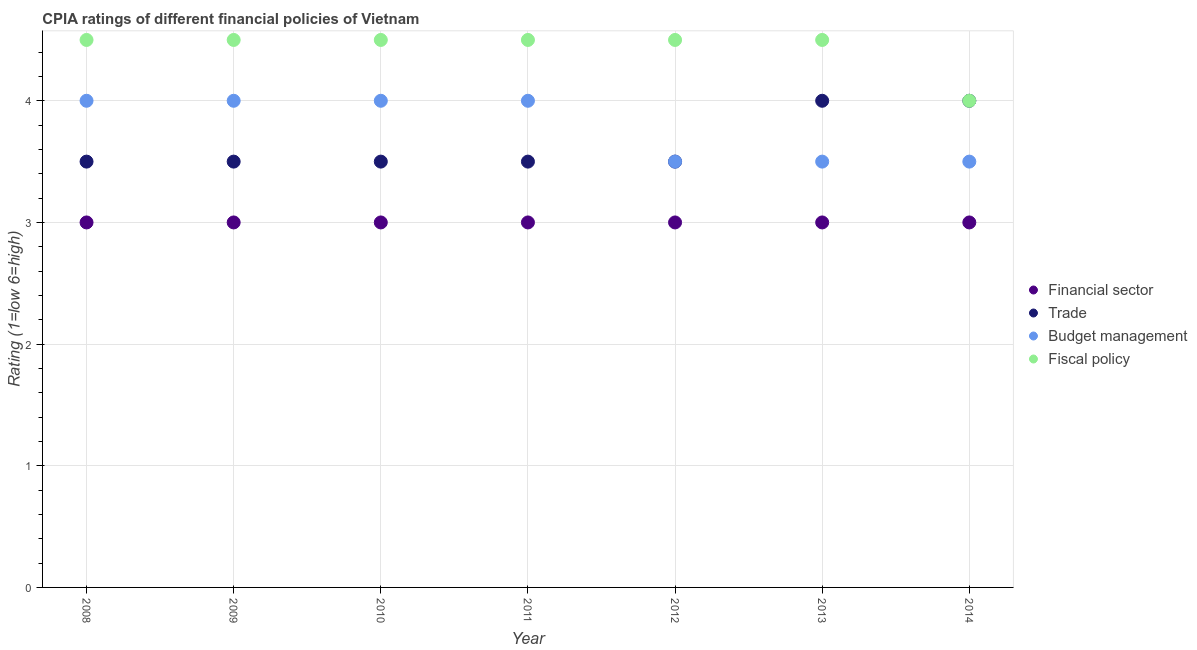Is the number of dotlines equal to the number of legend labels?
Provide a succinct answer. Yes. What is the cpia rating of budget management in 2009?
Your response must be concise. 4. Across all years, what is the maximum cpia rating of financial sector?
Ensure brevity in your answer.  3. In which year was the cpia rating of trade minimum?
Give a very brief answer. 2008. What is the total cpia rating of financial sector in the graph?
Make the answer very short. 21. What is the average cpia rating of fiscal policy per year?
Offer a very short reply. 4.43. In how many years, is the cpia rating of trade greater than 0.4?
Your response must be concise. 7. Is the cpia rating of financial sector in 2008 less than that in 2010?
Offer a very short reply. No. What is the difference between the highest and the second highest cpia rating of financial sector?
Make the answer very short. 0. In how many years, is the cpia rating of budget management greater than the average cpia rating of budget management taken over all years?
Your answer should be very brief. 4. Is it the case that in every year, the sum of the cpia rating of fiscal policy and cpia rating of budget management is greater than the sum of cpia rating of trade and cpia rating of financial sector?
Give a very brief answer. No. Is it the case that in every year, the sum of the cpia rating of financial sector and cpia rating of trade is greater than the cpia rating of budget management?
Offer a very short reply. Yes. Is the cpia rating of fiscal policy strictly greater than the cpia rating of financial sector over the years?
Make the answer very short. Yes. How many dotlines are there?
Your answer should be compact. 4. What is the difference between two consecutive major ticks on the Y-axis?
Your response must be concise. 1. How are the legend labels stacked?
Ensure brevity in your answer.  Vertical. What is the title of the graph?
Your response must be concise. CPIA ratings of different financial policies of Vietnam. What is the label or title of the X-axis?
Keep it short and to the point. Year. What is the label or title of the Y-axis?
Your answer should be very brief. Rating (1=low 6=high). What is the Rating (1=low 6=high) of Financial sector in 2008?
Offer a terse response. 3. What is the Rating (1=low 6=high) of Budget management in 2008?
Keep it short and to the point. 4. What is the Rating (1=low 6=high) of Fiscal policy in 2008?
Your response must be concise. 4.5. What is the Rating (1=low 6=high) of Trade in 2009?
Your answer should be compact. 3.5. What is the Rating (1=low 6=high) in Financial sector in 2010?
Provide a short and direct response. 3. What is the Rating (1=low 6=high) of Budget management in 2010?
Give a very brief answer. 4. What is the Rating (1=low 6=high) in Financial sector in 2011?
Offer a very short reply. 3. What is the Rating (1=low 6=high) of Budget management in 2011?
Your answer should be very brief. 4. What is the Rating (1=low 6=high) in Fiscal policy in 2011?
Make the answer very short. 4.5. What is the Rating (1=low 6=high) in Fiscal policy in 2012?
Provide a short and direct response. 4.5. What is the Rating (1=low 6=high) of Trade in 2013?
Offer a terse response. 4. What is the Rating (1=low 6=high) of Budget management in 2013?
Offer a terse response. 3.5. What is the Rating (1=low 6=high) of Fiscal policy in 2013?
Your answer should be very brief. 4.5. What is the Rating (1=low 6=high) in Financial sector in 2014?
Your answer should be compact. 3. What is the Rating (1=low 6=high) in Trade in 2014?
Provide a short and direct response. 4. What is the Rating (1=low 6=high) in Budget management in 2014?
Offer a very short reply. 3.5. Across all years, what is the maximum Rating (1=low 6=high) in Financial sector?
Your answer should be very brief. 3. Across all years, what is the maximum Rating (1=low 6=high) of Fiscal policy?
Provide a short and direct response. 4.5. Across all years, what is the minimum Rating (1=low 6=high) in Financial sector?
Give a very brief answer. 3. What is the total Rating (1=low 6=high) of Trade in the graph?
Offer a terse response. 25.5. What is the difference between the Rating (1=low 6=high) in Financial sector in 2008 and that in 2009?
Give a very brief answer. 0. What is the difference between the Rating (1=low 6=high) in Budget management in 2008 and that in 2009?
Offer a very short reply. 0. What is the difference between the Rating (1=low 6=high) in Trade in 2008 and that in 2010?
Your answer should be very brief. 0. What is the difference between the Rating (1=low 6=high) in Fiscal policy in 2008 and that in 2010?
Provide a short and direct response. 0. What is the difference between the Rating (1=low 6=high) in Financial sector in 2008 and that in 2011?
Your answer should be compact. 0. What is the difference between the Rating (1=low 6=high) in Trade in 2008 and that in 2011?
Your response must be concise. 0. What is the difference between the Rating (1=low 6=high) of Budget management in 2008 and that in 2011?
Keep it short and to the point. 0. What is the difference between the Rating (1=low 6=high) in Financial sector in 2008 and that in 2012?
Your response must be concise. 0. What is the difference between the Rating (1=low 6=high) in Trade in 2008 and that in 2012?
Ensure brevity in your answer.  0. What is the difference between the Rating (1=low 6=high) of Trade in 2008 and that in 2013?
Your response must be concise. -0.5. What is the difference between the Rating (1=low 6=high) in Budget management in 2009 and that in 2010?
Provide a short and direct response. 0. What is the difference between the Rating (1=low 6=high) of Trade in 2009 and that in 2011?
Provide a succinct answer. 0. What is the difference between the Rating (1=low 6=high) in Fiscal policy in 2009 and that in 2011?
Give a very brief answer. 0. What is the difference between the Rating (1=low 6=high) of Financial sector in 2009 and that in 2012?
Provide a short and direct response. 0. What is the difference between the Rating (1=low 6=high) of Trade in 2009 and that in 2012?
Give a very brief answer. 0. What is the difference between the Rating (1=low 6=high) of Fiscal policy in 2009 and that in 2012?
Offer a very short reply. 0. What is the difference between the Rating (1=low 6=high) of Trade in 2009 and that in 2013?
Provide a short and direct response. -0.5. What is the difference between the Rating (1=low 6=high) of Trade in 2009 and that in 2014?
Make the answer very short. -0.5. What is the difference between the Rating (1=low 6=high) in Budget management in 2009 and that in 2014?
Your answer should be very brief. 0.5. What is the difference between the Rating (1=low 6=high) of Financial sector in 2010 and that in 2011?
Give a very brief answer. 0. What is the difference between the Rating (1=low 6=high) of Budget management in 2010 and that in 2011?
Offer a terse response. 0. What is the difference between the Rating (1=low 6=high) of Financial sector in 2010 and that in 2012?
Your answer should be very brief. 0. What is the difference between the Rating (1=low 6=high) in Financial sector in 2010 and that in 2013?
Your answer should be compact. 0. What is the difference between the Rating (1=low 6=high) of Budget management in 2010 and that in 2013?
Give a very brief answer. 0.5. What is the difference between the Rating (1=low 6=high) in Fiscal policy in 2010 and that in 2013?
Offer a terse response. 0. What is the difference between the Rating (1=low 6=high) in Financial sector in 2010 and that in 2014?
Make the answer very short. 0. What is the difference between the Rating (1=low 6=high) of Trade in 2010 and that in 2014?
Your response must be concise. -0.5. What is the difference between the Rating (1=low 6=high) in Budget management in 2010 and that in 2014?
Give a very brief answer. 0.5. What is the difference between the Rating (1=low 6=high) in Fiscal policy in 2010 and that in 2014?
Keep it short and to the point. 0.5. What is the difference between the Rating (1=low 6=high) in Financial sector in 2011 and that in 2012?
Provide a succinct answer. 0. What is the difference between the Rating (1=low 6=high) in Trade in 2011 and that in 2012?
Ensure brevity in your answer.  0. What is the difference between the Rating (1=low 6=high) of Trade in 2011 and that in 2013?
Ensure brevity in your answer.  -0.5. What is the difference between the Rating (1=low 6=high) in Financial sector in 2011 and that in 2014?
Your response must be concise. 0. What is the difference between the Rating (1=low 6=high) in Budget management in 2012 and that in 2013?
Ensure brevity in your answer.  0. What is the difference between the Rating (1=low 6=high) in Fiscal policy in 2012 and that in 2014?
Ensure brevity in your answer.  0.5. What is the difference between the Rating (1=low 6=high) of Trade in 2013 and that in 2014?
Your answer should be very brief. 0. What is the difference between the Rating (1=low 6=high) of Budget management in 2013 and that in 2014?
Offer a very short reply. 0. What is the difference between the Rating (1=low 6=high) of Fiscal policy in 2013 and that in 2014?
Provide a short and direct response. 0.5. What is the difference between the Rating (1=low 6=high) of Financial sector in 2008 and the Rating (1=low 6=high) of Budget management in 2009?
Provide a succinct answer. -1. What is the difference between the Rating (1=low 6=high) in Financial sector in 2008 and the Rating (1=low 6=high) in Fiscal policy in 2009?
Your answer should be very brief. -1.5. What is the difference between the Rating (1=low 6=high) of Trade in 2008 and the Rating (1=low 6=high) of Budget management in 2009?
Give a very brief answer. -0.5. What is the difference between the Rating (1=low 6=high) in Budget management in 2008 and the Rating (1=low 6=high) in Fiscal policy in 2009?
Your answer should be very brief. -0.5. What is the difference between the Rating (1=low 6=high) in Financial sector in 2008 and the Rating (1=low 6=high) in Budget management in 2010?
Give a very brief answer. -1. What is the difference between the Rating (1=low 6=high) in Financial sector in 2008 and the Rating (1=low 6=high) in Fiscal policy in 2010?
Make the answer very short. -1.5. What is the difference between the Rating (1=low 6=high) of Trade in 2008 and the Rating (1=low 6=high) of Budget management in 2010?
Provide a short and direct response. -0.5. What is the difference between the Rating (1=low 6=high) in Trade in 2008 and the Rating (1=low 6=high) in Fiscal policy in 2010?
Provide a short and direct response. -1. What is the difference between the Rating (1=low 6=high) in Budget management in 2008 and the Rating (1=low 6=high) in Fiscal policy in 2010?
Provide a succinct answer. -0.5. What is the difference between the Rating (1=low 6=high) of Financial sector in 2008 and the Rating (1=low 6=high) of Trade in 2011?
Keep it short and to the point. -0.5. What is the difference between the Rating (1=low 6=high) in Trade in 2008 and the Rating (1=low 6=high) in Budget management in 2011?
Offer a terse response. -0.5. What is the difference between the Rating (1=low 6=high) of Trade in 2008 and the Rating (1=low 6=high) of Fiscal policy in 2011?
Ensure brevity in your answer.  -1. What is the difference between the Rating (1=low 6=high) in Budget management in 2008 and the Rating (1=low 6=high) in Fiscal policy in 2011?
Your response must be concise. -0.5. What is the difference between the Rating (1=low 6=high) of Financial sector in 2008 and the Rating (1=low 6=high) of Fiscal policy in 2012?
Your answer should be very brief. -1.5. What is the difference between the Rating (1=low 6=high) of Trade in 2008 and the Rating (1=low 6=high) of Fiscal policy in 2012?
Offer a terse response. -1. What is the difference between the Rating (1=low 6=high) in Budget management in 2008 and the Rating (1=low 6=high) in Fiscal policy in 2012?
Offer a terse response. -0.5. What is the difference between the Rating (1=low 6=high) of Trade in 2008 and the Rating (1=low 6=high) of Budget management in 2013?
Provide a succinct answer. 0. What is the difference between the Rating (1=low 6=high) in Financial sector in 2008 and the Rating (1=low 6=high) in Trade in 2014?
Provide a succinct answer. -1. What is the difference between the Rating (1=low 6=high) of Financial sector in 2008 and the Rating (1=low 6=high) of Fiscal policy in 2014?
Offer a very short reply. -1. What is the difference between the Rating (1=low 6=high) of Trade in 2008 and the Rating (1=low 6=high) of Budget management in 2014?
Offer a terse response. 0. What is the difference between the Rating (1=low 6=high) of Trade in 2008 and the Rating (1=low 6=high) of Fiscal policy in 2014?
Provide a short and direct response. -0.5. What is the difference between the Rating (1=low 6=high) in Financial sector in 2009 and the Rating (1=low 6=high) in Budget management in 2010?
Provide a short and direct response. -1. What is the difference between the Rating (1=low 6=high) in Financial sector in 2009 and the Rating (1=low 6=high) in Fiscal policy in 2010?
Make the answer very short. -1.5. What is the difference between the Rating (1=low 6=high) of Trade in 2009 and the Rating (1=low 6=high) of Budget management in 2010?
Offer a terse response. -0.5. What is the difference between the Rating (1=low 6=high) of Budget management in 2009 and the Rating (1=low 6=high) of Fiscal policy in 2010?
Provide a short and direct response. -0.5. What is the difference between the Rating (1=low 6=high) of Financial sector in 2009 and the Rating (1=low 6=high) of Budget management in 2011?
Give a very brief answer. -1. What is the difference between the Rating (1=low 6=high) of Trade in 2009 and the Rating (1=low 6=high) of Budget management in 2011?
Make the answer very short. -0.5. What is the difference between the Rating (1=low 6=high) of Financial sector in 2009 and the Rating (1=low 6=high) of Trade in 2012?
Ensure brevity in your answer.  -0.5. What is the difference between the Rating (1=low 6=high) in Trade in 2009 and the Rating (1=low 6=high) in Budget management in 2012?
Ensure brevity in your answer.  0. What is the difference between the Rating (1=low 6=high) of Financial sector in 2009 and the Rating (1=low 6=high) of Trade in 2013?
Keep it short and to the point. -1. What is the difference between the Rating (1=low 6=high) of Financial sector in 2009 and the Rating (1=low 6=high) of Fiscal policy in 2013?
Provide a short and direct response. -1.5. What is the difference between the Rating (1=low 6=high) in Budget management in 2009 and the Rating (1=low 6=high) in Fiscal policy in 2013?
Provide a short and direct response. -0.5. What is the difference between the Rating (1=low 6=high) of Financial sector in 2009 and the Rating (1=low 6=high) of Budget management in 2014?
Keep it short and to the point. -0.5. What is the difference between the Rating (1=low 6=high) of Trade in 2009 and the Rating (1=low 6=high) of Fiscal policy in 2014?
Make the answer very short. -0.5. What is the difference between the Rating (1=low 6=high) in Budget management in 2009 and the Rating (1=low 6=high) in Fiscal policy in 2014?
Provide a short and direct response. 0. What is the difference between the Rating (1=low 6=high) of Financial sector in 2010 and the Rating (1=low 6=high) of Trade in 2011?
Give a very brief answer. -0.5. What is the difference between the Rating (1=low 6=high) of Trade in 2010 and the Rating (1=low 6=high) of Budget management in 2011?
Ensure brevity in your answer.  -0.5. What is the difference between the Rating (1=low 6=high) in Trade in 2010 and the Rating (1=low 6=high) in Fiscal policy in 2011?
Your answer should be compact. -1. What is the difference between the Rating (1=low 6=high) in Budget management in 2010 and the Rating (1=low 6=high) in Fiscal policy in 2011?
Ensure brevity in your answer.  -0.5. What is the difference between the Rating (1=low 6=high) of Trade in 2010 and the Rating (1=low 6=high) of Budget management in 2012?
Provide a succinct answer. 0. What is the difference between the Rating (1=low 6=high) in Trade in 2010 and the Rating (1=low 6=high) in Fiscal policy in 2012?
Your answer should be compact. -1. What is the difference between the Rating (1=low 6=high) of Financial sector in 2010 and the Rating (1=low 6=high) of Trade in 2013?
Ensure brevity in your answer.  -1. What is the difference between the Rating (1=low 6=high) of Financial sector in 2010 and the Rating (1=low 6=high) of Budget management in 2013?
Your answer should be very brief. -0.5. What is the difference between the Rating (1=low 6=high) in Financial sector in 2010 and the Rating (1=low 6=high) in Fiscal policy in 2013?
Provide a succinct answer. -1.5. What is the difference between the Rating (1=low 6=high) of Trade in 2010 and the Rating (1=low 6=high) of Budget management in 2013?
Your answer should be compact. 0. What is the difference between the Rating (1=low 6=high) of Trade in 2010 and the Rating (1=low 6=high) of Fiscal policy in 2013?
Keep it short and to the point. -1. What is the difference between the Rating (1=low 6=high) in Financial sector in 2010 and the Rating (1=low 6=high) in Trade in 2014?
Give a very brief answer. -1. What is the difference between the Rating (1=low 6=high) in Trade in 2010 and the Rating (1=low 6=high) in Fiscal policy in 2014?
Your answer should be compact. -0.5. What is the difference between the Rating (1=low 6=high) of Financial sector in 2011 and the Rating (1=low 6=high) of Fiscal policy in 2012?
Give a very brief answer. -1.5. What is the difference between the Rating (1=low 6=high) in Budget management in 2011 and the Rating (1=low 6=high) in Fiscal policy in 2012?
Your answer should be compact. -0.5. What is the difference between the Rating (1=low 6=high) in Trade in 2011 and the Rating (1=low 6=high) in Fiscal policy in 2013?
Your answer should be very brief. -1. What is the difference between the Rating (1=low 6=high) in Financial sector in 2011 and the Rating (1=low 6=high) in Fiscal policy in 2014?
Your answer should be compact. -1. What is the difference between the Rating (1=low 6=high) in Trade in 2011 and the Rating (1=low 6=high) in Budget management in 2014?
Keep it short and to the point. 0. What is the difference between the Rating (1=low 6=high) of Trade in 2011 and the Rating (1=low 6=high) of Fiscal policy in 2014?
Your answer should be compact. -0.5. What is the difference between the Rating (1=low 6=high) of Budget management in 2011 and the Rating (1=low 6=high) of Fiscal policy in 2014?
Offer a terse response. 0. What is the difference between the Rating (1=low 6=high) in Financial sector in 2012 and the Rating (1=low 6=high) in Budget management in 2013?
Your answer should be compact. -0.5. What is the difference between the Rating (1=low 6=high) in Trade in 2012 and the Rating (1=low 6=high) in Fiscal policy in 2013?
Your answer should be compact. -1. What is the difference between the Rating (1=low 6=high) in Financial sector in 2012 and the Rating (1=low 6=high) in Trade in 2014?
Ensure brevity in your answer.  -1. What is the difference between the Rating (1=low 6=high) of Trade in 2013 and the Rating (1=low 6=high) of Budget management in 2014?
Your response must be concise. 0.5. What is the average Rating (1=low 6=high) of Trade per year?
Your response must be concise. 3.64. What is the average Rating (1=low 6=high) in Budget management per year?
Ensure brevity in your answer.  3.79. What is the average Rating (1=low 6=high) of Fiscal policy per year?
Give a very brief answer. 4.43. In the year 2008, what is the difference between the Rating (1=low 6=high) in Financial sector and Rating (1=low 6=high) in Trade?
Offer a very short reply. -0.5. In the year 2008, what is the difference between the Rating (1=low 6=high) of Financial sector and Rating (1=low 6=high) of Budget management?
Offer a terse response. -1. In the year 2008, what is the difference between the Rating (1=low 6=high) in Trade and Rating (1=low 6=high) in Fiscal policy?
Your answer should be very brief. -1. In the year 2008, what is the difference between the Rating (1=low 6=high) of Budget management and Rating (1=low 6=high) of Fiscal policy?
Make the answer very short. -0.5. In the year 2009, what is the difference between the Rating (1=low 6=high) of Financial sector and Rating (1=low 6=high) of Budget management?
Keep it short and to the point. -1. In the year 2009, what is the difference between the Rating (1=low 6=high) of Financial sector and Rating (1=low 6=high) of Fiscal policy?
Offer a very short reply. -1.5. In the year 2009, what is the difference between the Rating (1=low 6=high) of Trade and Rating (1=low 6=high) of Budget management?
Give a very brief answer. -0.5. In the year 2009, what is the difference between the Rating (1=low 6=high) of Budget management and Rating (1=low 6=high) of Fiscal policy?
Offer a terse response. -0.5. In the year 2010, what is the difference between the Rating (1=low 6=high) in Financial sector and Rating (1=low 6=high) in Trade?
Make the answer very short. -0.5. In the year 2010, what is the difference between the Rating (1=low 6=high) in Financial sector and Rating (1=low 6=high) in Budget management?
Your answer should be compact. -1. In the year 2010, what is the difference between the Rating (1=low 6=high) of Financial sector and Rating (1=low 6=high) of Fiscal policy?
Keep it short and to the point. -1.5. In the year 2010, what is the difference between the Rating (1=low 6=high) of Trade and Rating (1=low 6=high) of Budget management?
Make the answer very short. -0.5. In the year 2010, what is the difference between the Rating (1=low 6=high) of Trade and Rating (1=low 6=high) of Fiscal policy?
Keep it short and to the point. -1. In the year 2010, what is the difference between the Rating (1=low 6=high) in Budget management and Rating (1=low 6=high) in Fiscal policy?
Your answer should be compact. -0.5. In the year 2011, what is the difference between the Rating (1=low 6=high) in Financial sector and Rating (1=low 6=high) in Budget management?
Your response must be concise. -1. In the year 2011, what is the difference between the Rating (1=low 6=high) of Trade and Rating (1=low 6=high) of Fiscal policy?
Your answer should be compact. -1. In the year 2012, what is the difference between the Rating (1=low 6=high) in Financial sector and Rating (1=low 6=high) in Fiscal policy?
Make the answer very short. -1.5. In the year 2012, what is the difference between the Rating (1=low 6=high) in Trade and Rating (1=low 6=high) in Budget management?
Provide a succinct answer. 0. In the year 2012, what is the difference between the Rating (1=low 6=high) in Trade and Rating (1=low 6=high) in Fiscal policy?
Give a very brief answer. -1. In the year 2012, what is the difference between the Rating (1=low 6=high) in Budget management and Rating (1=low 6=high) in Fiscal policy?
Give a very brief answer. -1. In the year 2013, what is the difference between the Rating (1=low 6=high) of Financial sector and Rating (1=low 6=high) of Trade?
Ensure brevity in your answer.  -1. In the year 2013, what is the difference between the Rating (1=low 6=high) in Financial sector and Rating (1=low 6=high) in Budget management?
Your answer should be very brief. -0.5. In the year 2013, what is the difference between the Rating (1=low 6=high) of Financial sector and Rating (1=low 6=high) of Fiscal policy?
Make the answer very short. -1.5. In the year 2013, what is the difference between the Rating (1=low 6=high) in Budget management and Rating (1=low 6=high) in Fiscal policy?
Keep it short and to the point. -1. In the year 2014, what is the difference between the Rating (1=low 6=high) in Financial sector and Rating (1=low 6=high) in Budget management?
Offer a very short reply. -0.5. In the year 2014, what is the difference between the Rating (1=low 6=high) in Trade and Rating (1=low 6=high) in Budget management?
Offer a very short reply. 0.5. In the year 2014, what is the difference between the Rating (1=low 6=high) of Trade and Rating (1=low 6=high) of Fiscal policy?
Offer a very short reply. 0. What is the ratio of the Rating (1=low 6=high) of Financial sector in 2008 to that in 2009?
Offer a very short reply. 1. What is the ratio of the Rating (1=low 6=high) in Trade in 2008 to that in 2009?
Provide a succinct answer. 1. What is the ratio of the Rating (1=low 6=high) of Budget management in 2008 to that in 2009?
Provide a short and direct response. 1. What is the ratio of the Rating (1=low 6=high) in Fiscal policy in 2008 to that in 2009?
Offer a terse response. 1. What is the ratio of the Rating (1=low 6=high) in Trade in 2008 to that in 2010?
Provide a short and direct response. 1. What is the ratio of the Rating (1=low 6=high) in Financial sector in 2008 to that in 2011?
Give a very brief answer. 1. What is the ratio of the Rating (1=low 6=high) of Trade in 2008 to that in 2011?
Your answer should be very brief. 1. What is the ratio of the Rating (1=low 6=high) of Financial sector in 2008 to that in 2012?
Keep it short and to the point. 1. What is the ratio of the Rating (1=low 6=high) of Trade in 2008 to that in 2012?
Ensure brevity in your answer.  1. What is the ratio of the Rating (1=low 6=high) of Budget management in 2008 to that in 2012?
Keep it short and to the point. 1.14. What is the ratio of the Rating (1=low 6=high) of Fiscal policy in 2008 to that in 2012?
Provide a short and direct response. 1. What is the ratio of the Rating (1=low 6=high) in Trade in 2008 to that in 2013?
Provide a short and direct response. 0.88. What is the ratio of the Rating (1=low 6=high) of Fiscal policy in 2008 to that in 2013?
Offer a very short reply. 1. What is the ratio of the Rating (1=low 6=high) of Budget management in 2008 to that in 2014?
Your response must be concise. 1.14. What is the ratio of the Rating (1=low 6=high) of Financial sector in 2009 to that in 2010?
Make the answer very short. 1. What is the ratio of the Rating (1=low 6=high) of Budget management in 2009 to that in 2010?
Offer a terse response. 1. What is the ratio of the Rating (1=low 6=high) of Fiscal policy in 2009 to that in 2010?
Your response must be concise. 1. What is the ratio of the Rating (1=low 6=high) in Trade in 2009 to that in 2011?
Give a very brief answer. 1. What is the ratio of the Rating (1=low 6=high) of Budget management in 2009 to that in 2011?
Offer a very short reply. 1. What is the ratio of the Rating (1=low 6=high) in Fiscal policy in 2009 to that in 2011?
Your answer should be compact. 1. What is the ratio of the Rating (1=low 6=high) in Budget management in 2009 to that in 2012?
Provide a short and direct response. 1.14. What is the ratio of the Rating (1=low 6=high) in Financial sector in 2009 to that in 2013?
Provide a succinct answer. 1. What is the ratio of the Rating (1=low 6=high) of Budget management in 2009 to that in 2013?
Offer a very short reply. 1.14. What is the ratio of the Rating (1=low 6=high) of Fiscal policy in 2009 to that in 2013?
Offer a very short reply. 1. What is the ratio of the Rating (1=low 6=high) in Budget management in 2009 to that in 2014?
Your answer should be very brief. 1.14. What is the ratio of the Rating (1=low 6=high) of Financial sector in 2010 to that in 2011?
Provide a short and direct response. 1. What is the ratio of the Rating (1=low 6=high) in Trade in 2010 to that in 2011?
Your answer should be compact. 1. What is the ratio of the Rating (1=low 6=high) of Budget management in 2010 to that in 2011?
Offer a terse response. 1. What is the ratio of the Rating (1=low 6=high) of Financial sector in 2010 to that in 2012?
Your answer should be very brief. 1. What is the ratio of the Rating (1=low 6=high) in Financial sector in 2010 to that in 2013?
Give a very brief answer. 1. What is the ratio of the Rating (1=low 6=high) of Budget management in 2010 to that in 2014?
Offer a very short reply. 1.14. What is the ratio of the Rating (1=low 6=high) in Trade in 2011 to that in 2012?
Your answer should be very brief. 1. What is the ratio of the Rating (1=low 6=high) of Fiscal policy in 2011 to that in 2012?
Offer a very short reply. 1. What is the ratio of the Rating (1=low 6=high) of Trade in 2011 to that in 2013?
Provide a succinct answer. 0.88. What is the ratio of the Rating (1=low 6=high) in Budget management in 2011 to that in 2013?
Make the answer very short. 1.14. What is the ratio of the Rating (1=low 6=high) in Financial sector in 2011 to that in 2014?
Offer a very short reply. 1. What is the ratio of the Rating (1=low 6=high) of Budget management in 2011 to that in 2014?
Your answer should be compact. 1.14. What is the ratio of the Rating (1=low 6=high) in Budget management in 2012 to that in 2013?
Keep it short and to the point. 1. What is the ratio of the Rating (1=low 6=high) in Fiscal policy in 2012 to that in 2013?
Provide a succinct answer. 1. What is the ratio of the Rating (1=low 6=high) of Financial sector in 2012 to that in 2014?
Your answer should be compact. 1. What is the ratio of the Rating (1=low 6=high) of Trade in 2012 to that in 2014?
Give a very brief answer. 0.88. What is the ratio of the Rating (1=low 6=high) of Financial sector in 2013 to that in 2014?
Your answer should be compact. 1. What is the ratio of the Rating (1=low 6=high) of Budget management in 2013 to that in 2014?
Your answer should be very brief. 1. What is the difference between the highest and the second highest Rating (1=low 6=high) of Trade?
Make the answer very short. 0. What is the difference between the highest and the lowest Rating (1=low 6=high) of Budget management?
Offer a very short reply. 0.5. 